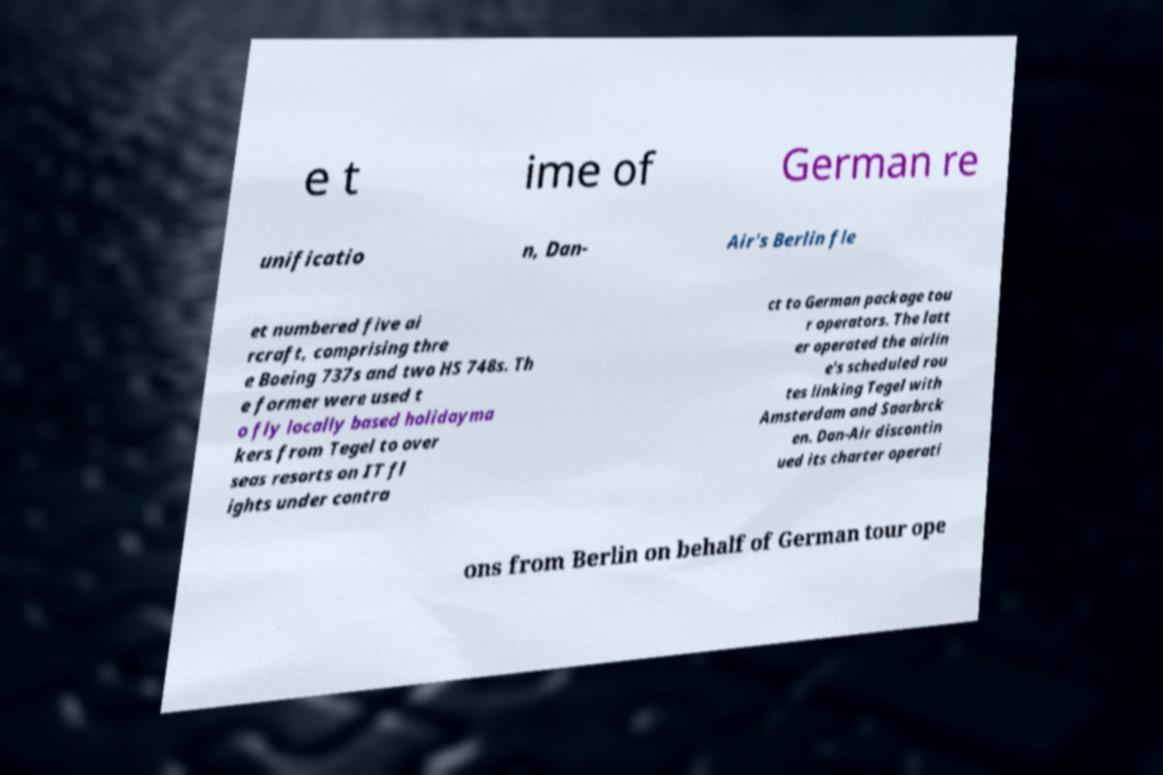For documentation purposes, I need the text within this image transcribed. Could you provide that? e t ime of German re unificatio n, Dan- Air's Berlin fle et numbered five ai rcraft, comprising thre e Boeing 737s and two HS 748s. Th e former were used t o fly locally based holidayma kers from Tegel to over seas resorts on IT fl ights under contra ct to German package tou r operators. The latt er operated the airlin e's scheduled rou tes linking Tegel with Amsterdam and Saarbrck en. Dan-Air discontin ued its charter operati ons from Berlin on behalf of German tour ope 